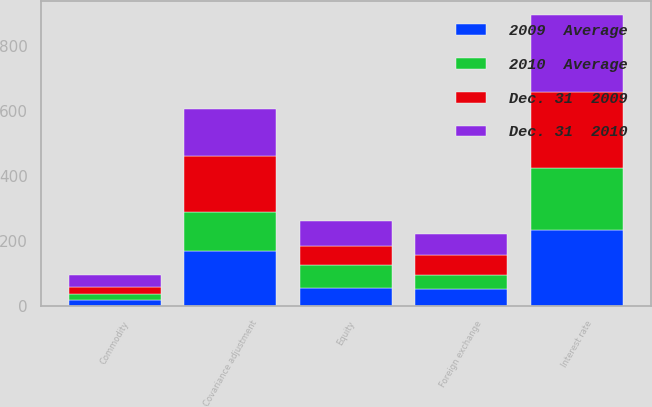<chart> <loc_0><loc_0><loc_500><loc_500><stacked_bar_chart><ecel><fcel>Interest rate<fcel>Foreign exchange<fcel>Equity<fcel>Commodity<fcel>Covariance adjustment<nl><fcel>2009  Average<fcel>235<fcel>52<fcel>56<fcel>19<fcel>171<nl><fcel>Dec. 31  2009<fcel>234<fcel>61<fcel>59<fcel>23<fcel>172<nl><fcel>2010  Average<fcel>191<fcel>45<fcel>69<fcel>18<fcel>118<nl><fcel>Dec. 31  2010<fcel>235<fcel>65<fcel>79<fcel>34<fcel>147<nl></chart> 